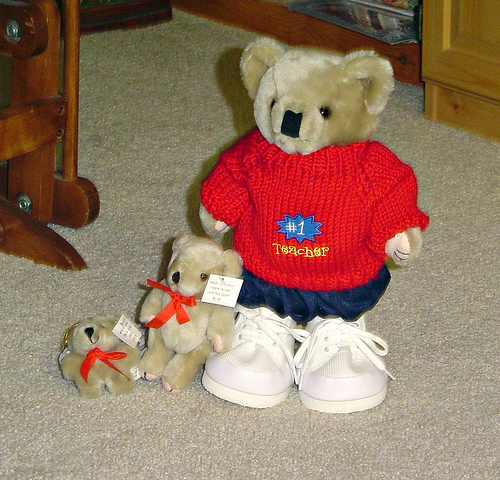<image>
Is there a shoes in front of the sweater? No. The shoes is not in front of the sweater. The spatial positioning shows a different relationship between these objects. 